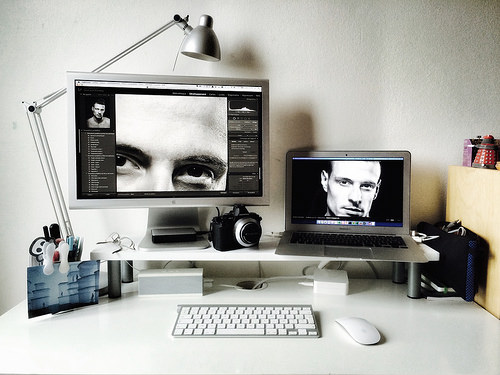<image>
Is there a monitor behind the camera? Yes. From this viewpoint, the monitor is positioned behind the camera, with the camera partially or fully occluding the monitor. 